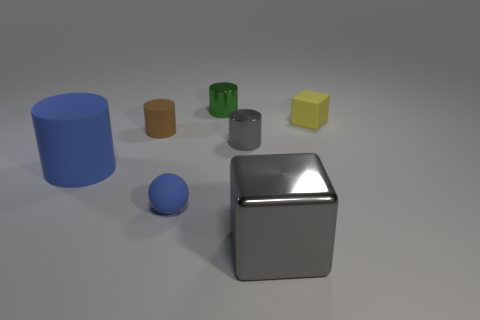Subtract 1 cylinders. How many cylinders are left? 3 Subtract all green cylinders. How many cylinders are left? 3 Subtract all tiny green cylinders. How many cylinders are left? 3 Add 3 yellow cubes. How many objects exist? 10 Subtract all purple cylinders. Subtract all brown balls. How many cylinders are left? 4 Subtract all blocks. How many objects are left? 5 Add 2 small cylinders. How many small cylinders are left? 5 Add 5 large metal objects. How many large metal objects exist? 6 Subtract 0 cyan cylinders. How many objects are left? 7 Subtract all big purple balls. Subtract all small green metallic things. How many objects are left? 6 